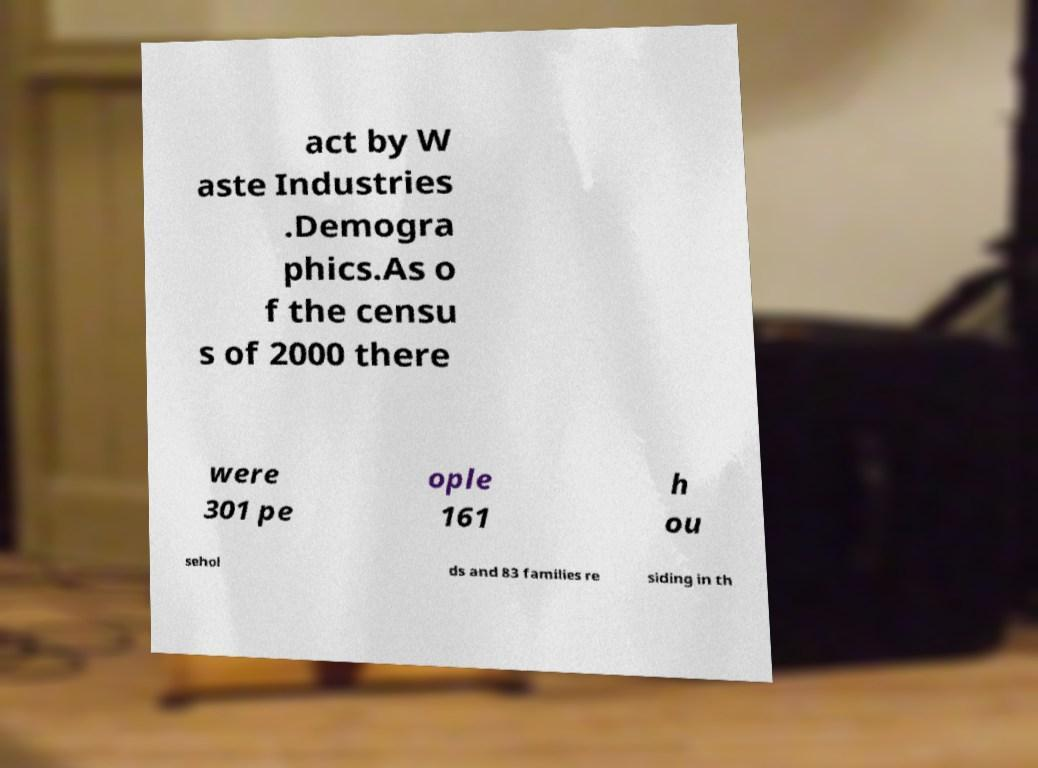I need the written content from this picture converted into text. Can you do that? act by W aste Industries .Demogra phics.As o f the censu s of 2000 there were 301 pe ople 161 h ou sehol ds and 83 families re siding in th 